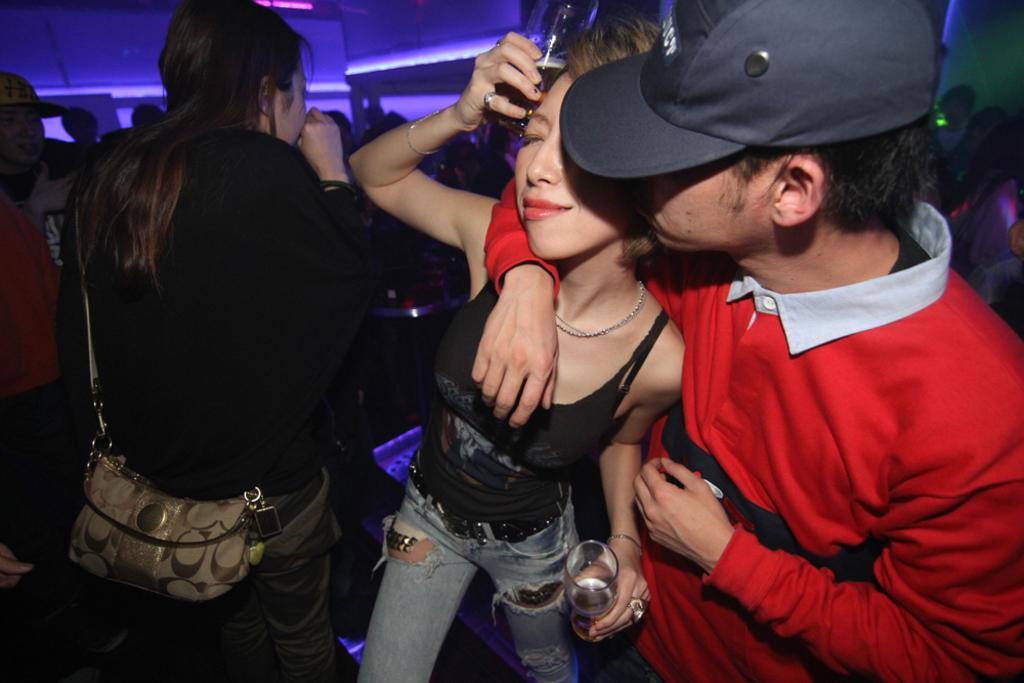Describe this image in one or two sentences. In this image there are some persons standing standing in middle of this image. The person standing in middle of this image is holding a glass and the person is left side to her is holding a handbag and the person at right side is wearing a cap and there is a wall in the background. 